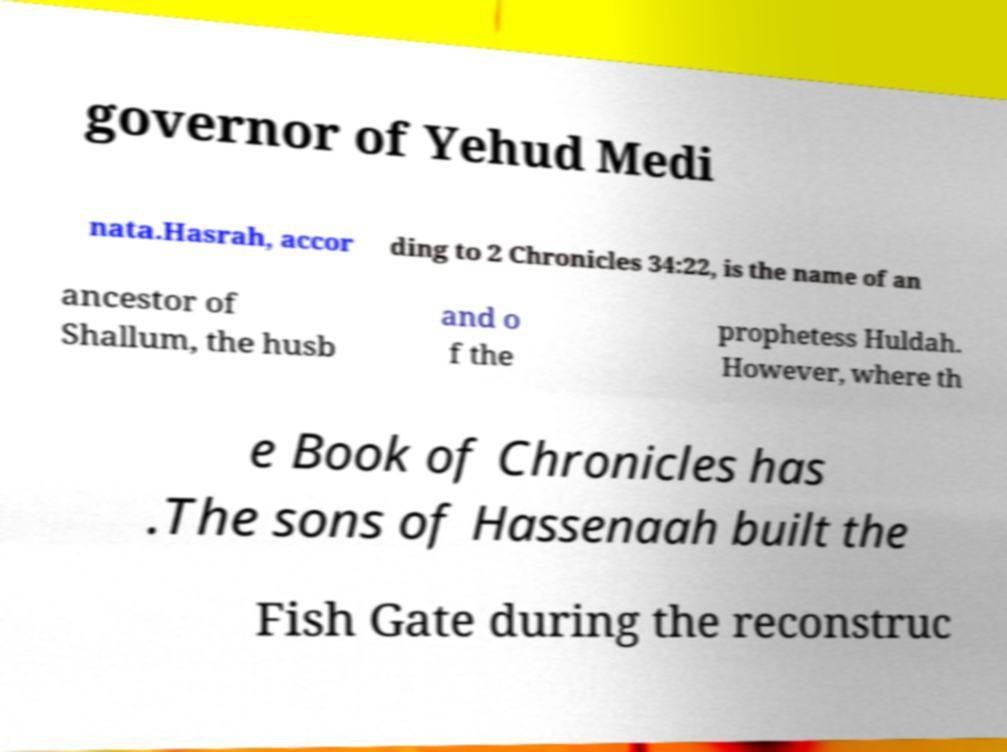Please read and relay the text visible in this image. What does it say? governor of Yehud Medi nata.Hasrah, accor ding to 2 Chronicles 34:22, is the name of an ancestor of Shallum, the husb and o f the prophetess Huldah. However, where th e Book of Chronicles has .The sons of Hassenaah built the Fish Gate during the reconstruc 